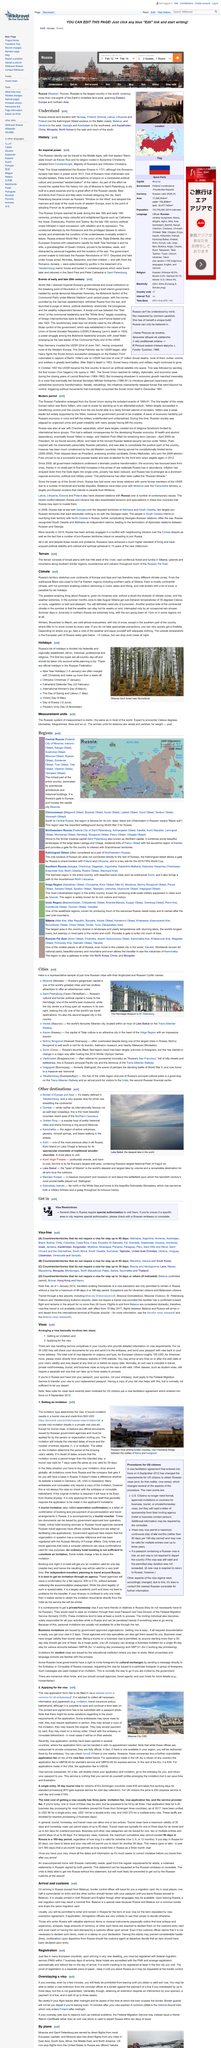Mention a couple of crucial points in this snapshot. During the summer, the sun sets as late as 11pm, and in some regions it does not set at all. Saint Petersburg is the second largest city in Russia. It is certain that the city of St. Petersburg is home to the renowned Hermitage Museum, which is a prominent attraction for art and history enthusiasts from all corners of the world. Yes, Russian summers are hot, and it is necessary to use sunscreen to protect oneself from the harmful effects of the sun's rays. Moscow is the capital of Russia, and it is known for its rich history, culture, and architecture. 